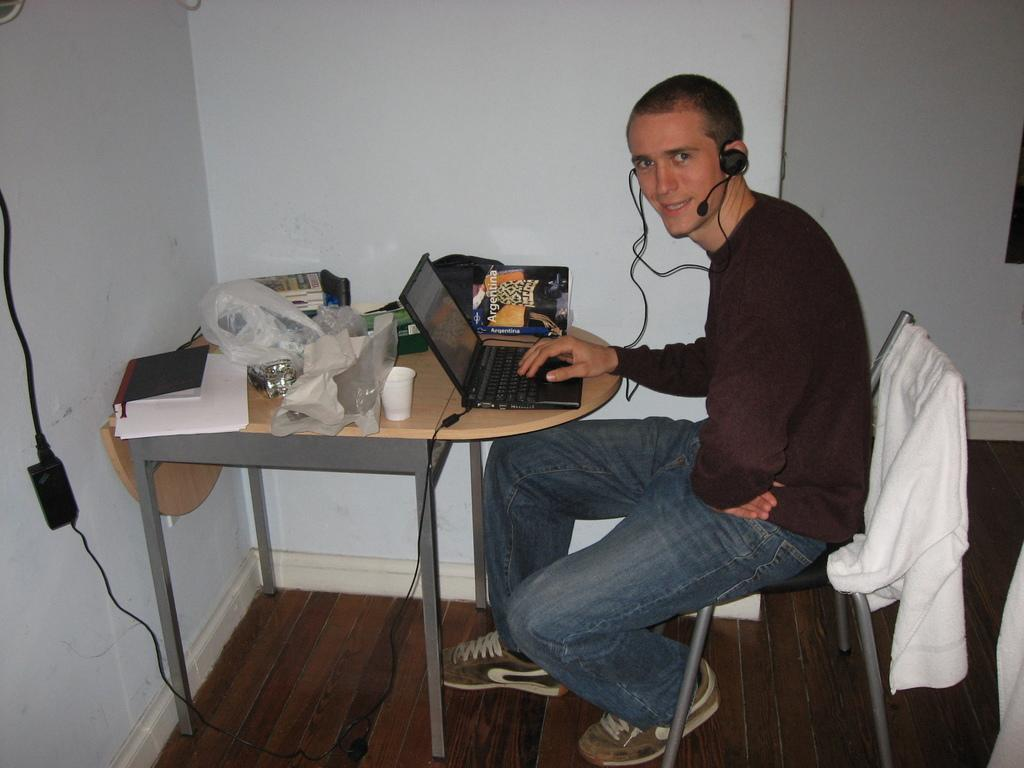Who is present in the image? There is a man in the image. What is the man doing in the image? The man is sitting in a chair and working on a laptop. What can be seen behind the man in the image? There is a wall in the image. What type of treatment is the squirrel receiving from the man in the image? There is no squirrel present in the image, and therefore no treatment can be observed. 